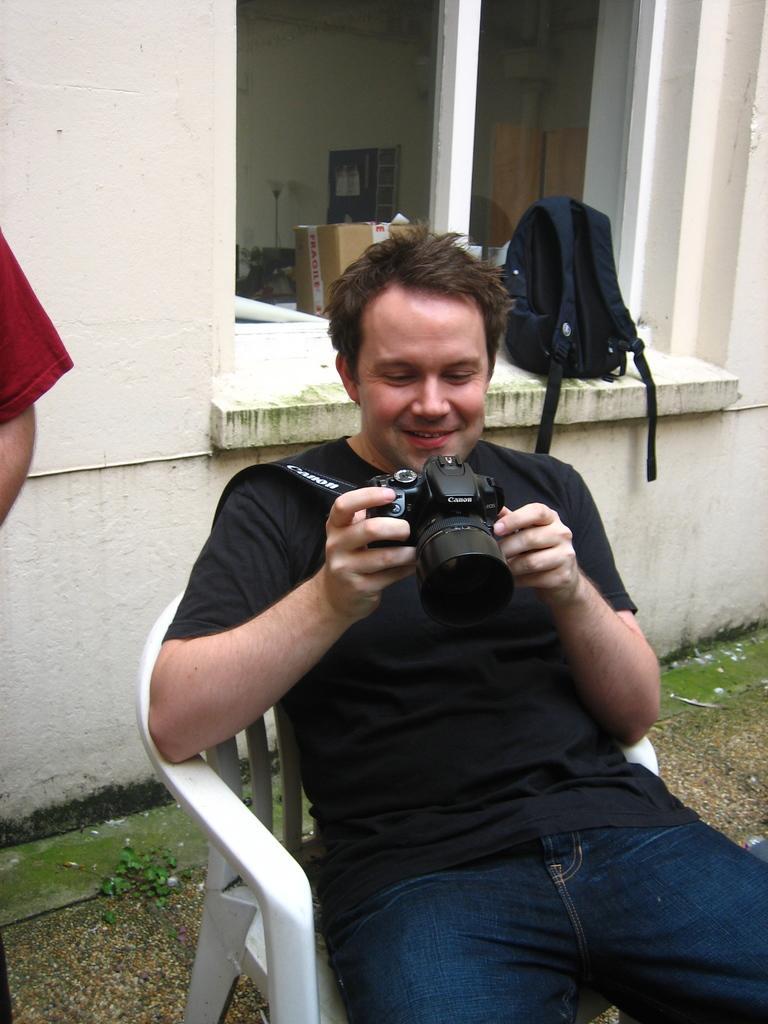Please provide a concise description of this image. in the picture a man is sitting on the chair holding a camera there is bag behind the man. 